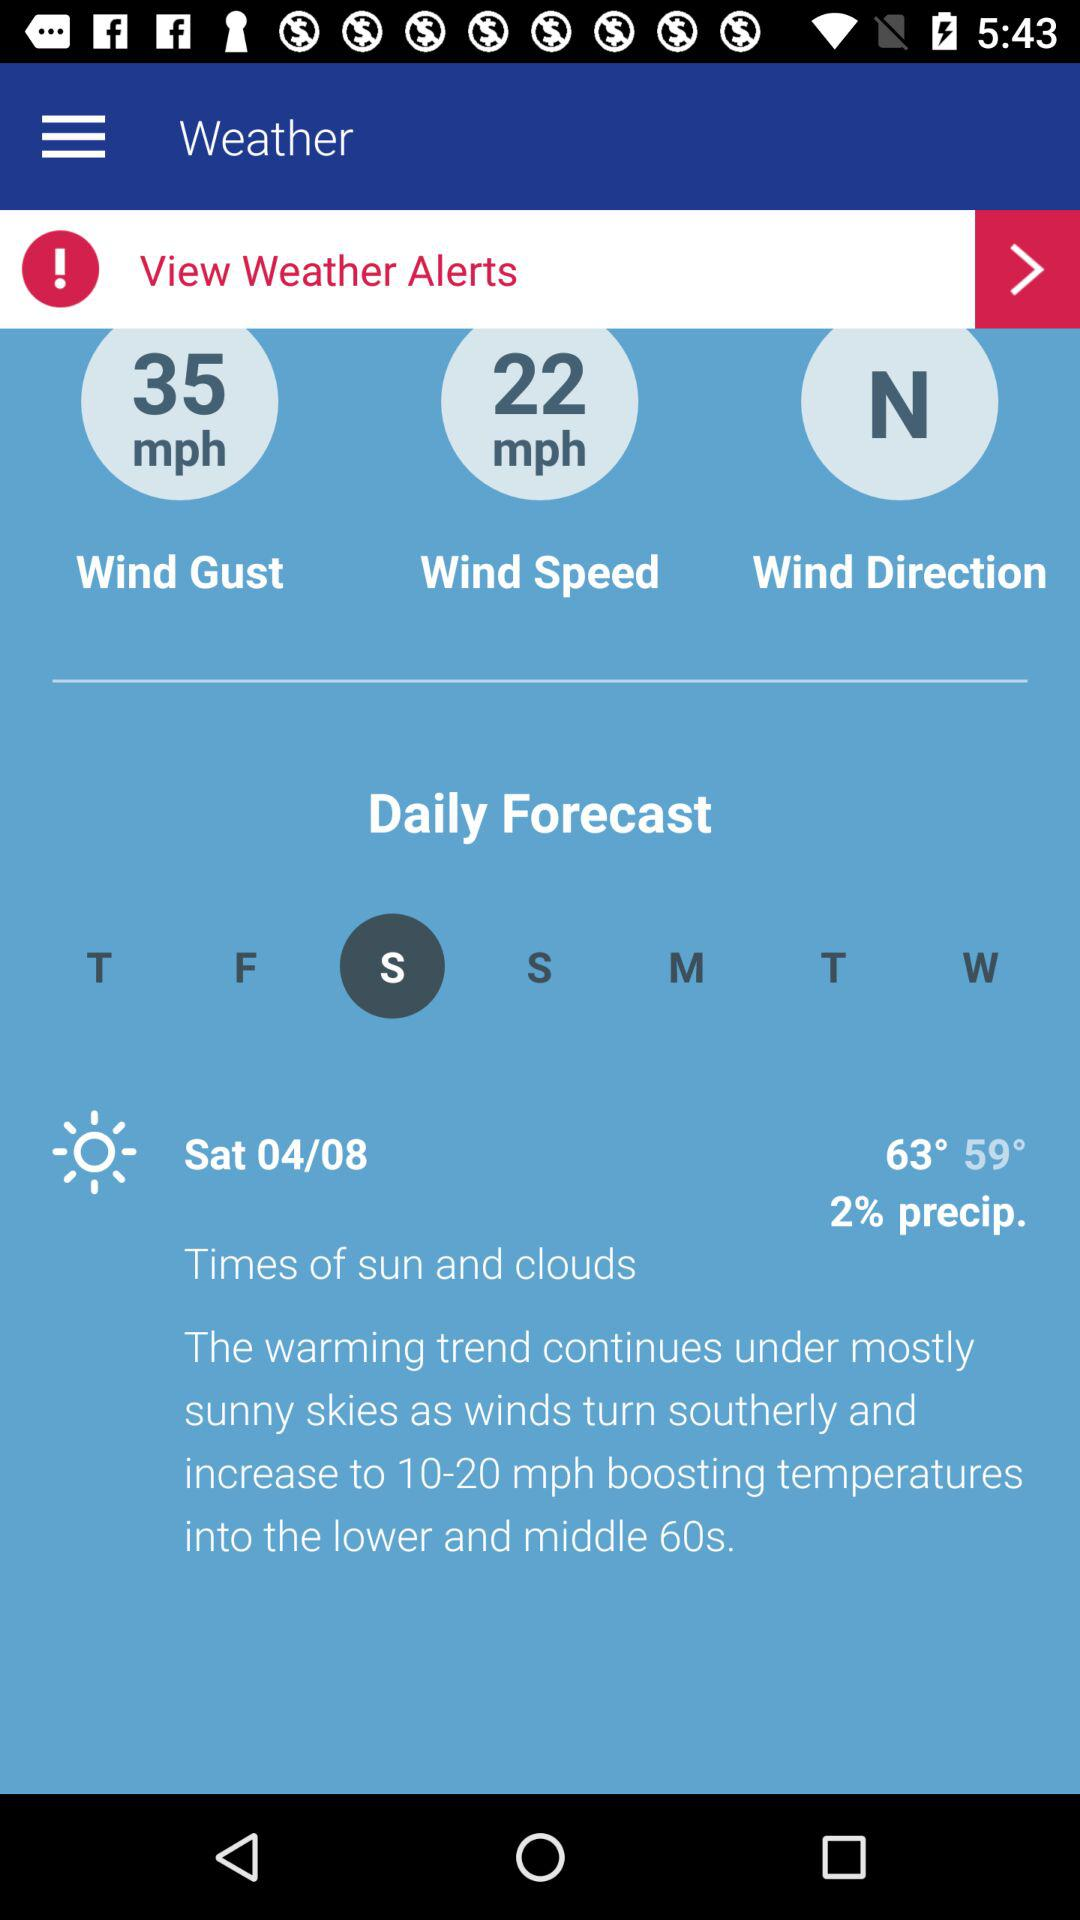What is the percentage of precipitation? The percentage of precipitation is 2. 